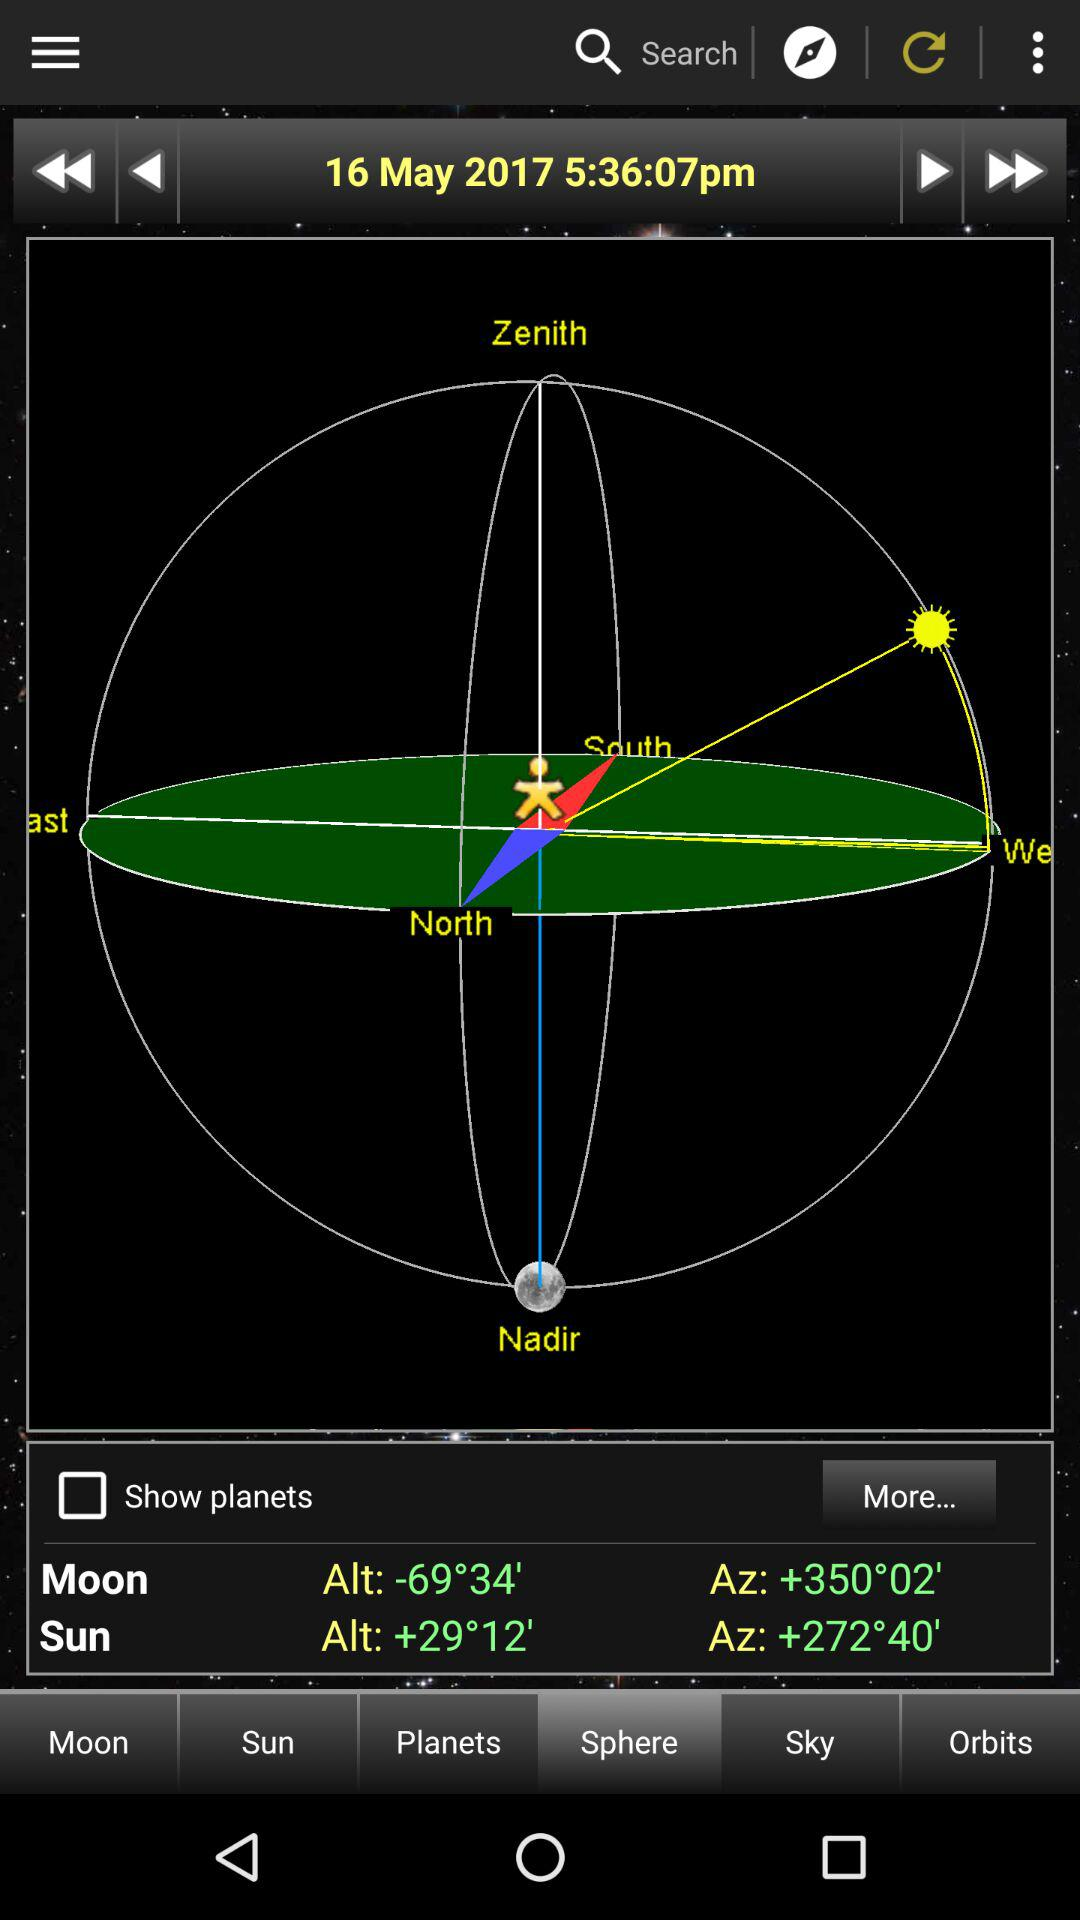What is the difference in altitude between the Moon and the Sun?
Answer the question using a single word or phrase. 40°22' 